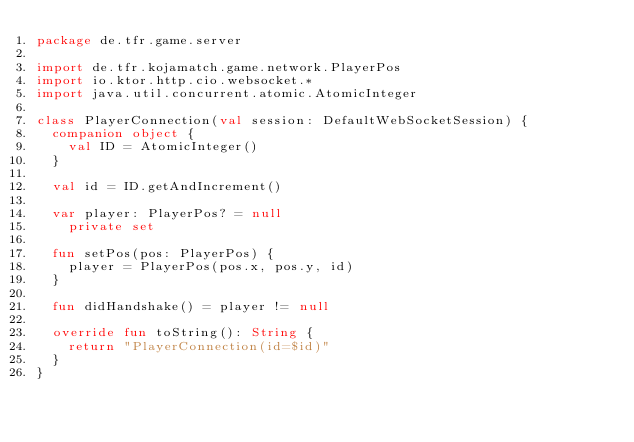<code> <loc_0><loc_0><loc_500><loc_500><_Kotlin_>package de.tfr.game.server

import de.tfr.kojamatch.game.network.PlayerPos
import io.ktor.http.cio.websocket.*
import java.util.concurrent.atomic.AtomicInteger

class PlayerConnection(val session: DefaultWebSocketSession) {
  companion object {
    val ID = AtomicInteger()
  }

  val id = ID.getAndIncrement()

  var player: PlayerPos? = null
    private set

  fun setPos(pos: PlayerPos) {
    player = PlayerPos(pos.x, pos.y, id)
  }

  fun didHandshake() = player != null

  override fun toString(): String {
    return "PlayerConnection(id=$id)"
  }
}</code> 